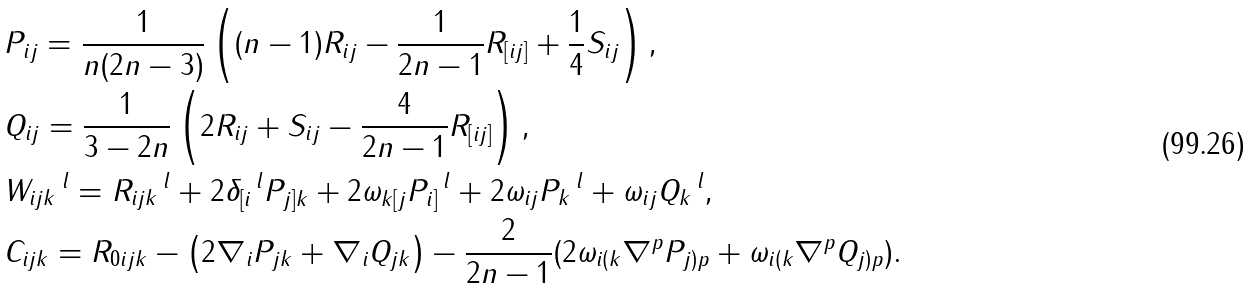Convert formula to latex. <formula><loc_0><loc_0><loc_500><loc_500>& P _ { i j } = \frac { 1 } { n ( 2 n - 3 ) } \left ( ( n - 1 ) R _ { i j } - \frac { 1 } { 2 n - 1 } R _ { [ i j ] } + \frac { 1 } { 4 } S _ { i j } \right ) , \\ & Q _ { i j } = \frac { 1 } { 3 - 2 n } \left ( 2 R _ { i j } + S _ { i j } - \frac { 4 } { 2 n - 1 } R _ { [ i j ] } \right ) , \\ & W _ { i j k } \, ^ { l } = R _ { i j k } \, ^ { l } + 2 \delta _ { [ i } \, ^ { l } P _ { j ] k } + 2 \omega _ { k [ j } P _ { i ] } \, ^ { l } + 2 \omega _ { i j } P _ { k } \, ^ { l } + \omega _ { i j } Q _ { k } \, ^ { l } , \\ & C _ { i j k } = R _ { 0 i j k } - \left ( 2 \nabla _ { i } P _ { j k } + \nabla _ { i } Q _ { j k } \right ) - \frac { 2 } { 2 n - 1 } ( 2 \omega _ { i ( k } \nabla ^ { p } P _ { j ) p } + \omega _ { i ( k } \nabla ^ { p } Q _ { j ) p } ) .</formula> 